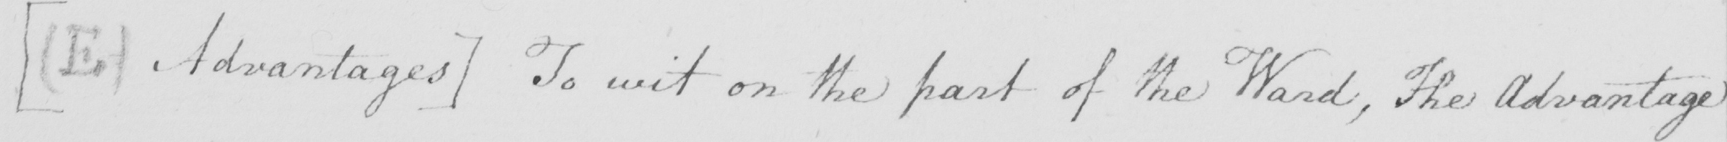Can you tell me what this handwritten text says? [  ( E )  Advantages ]  To wit on the part of the Ward , the Advantage 